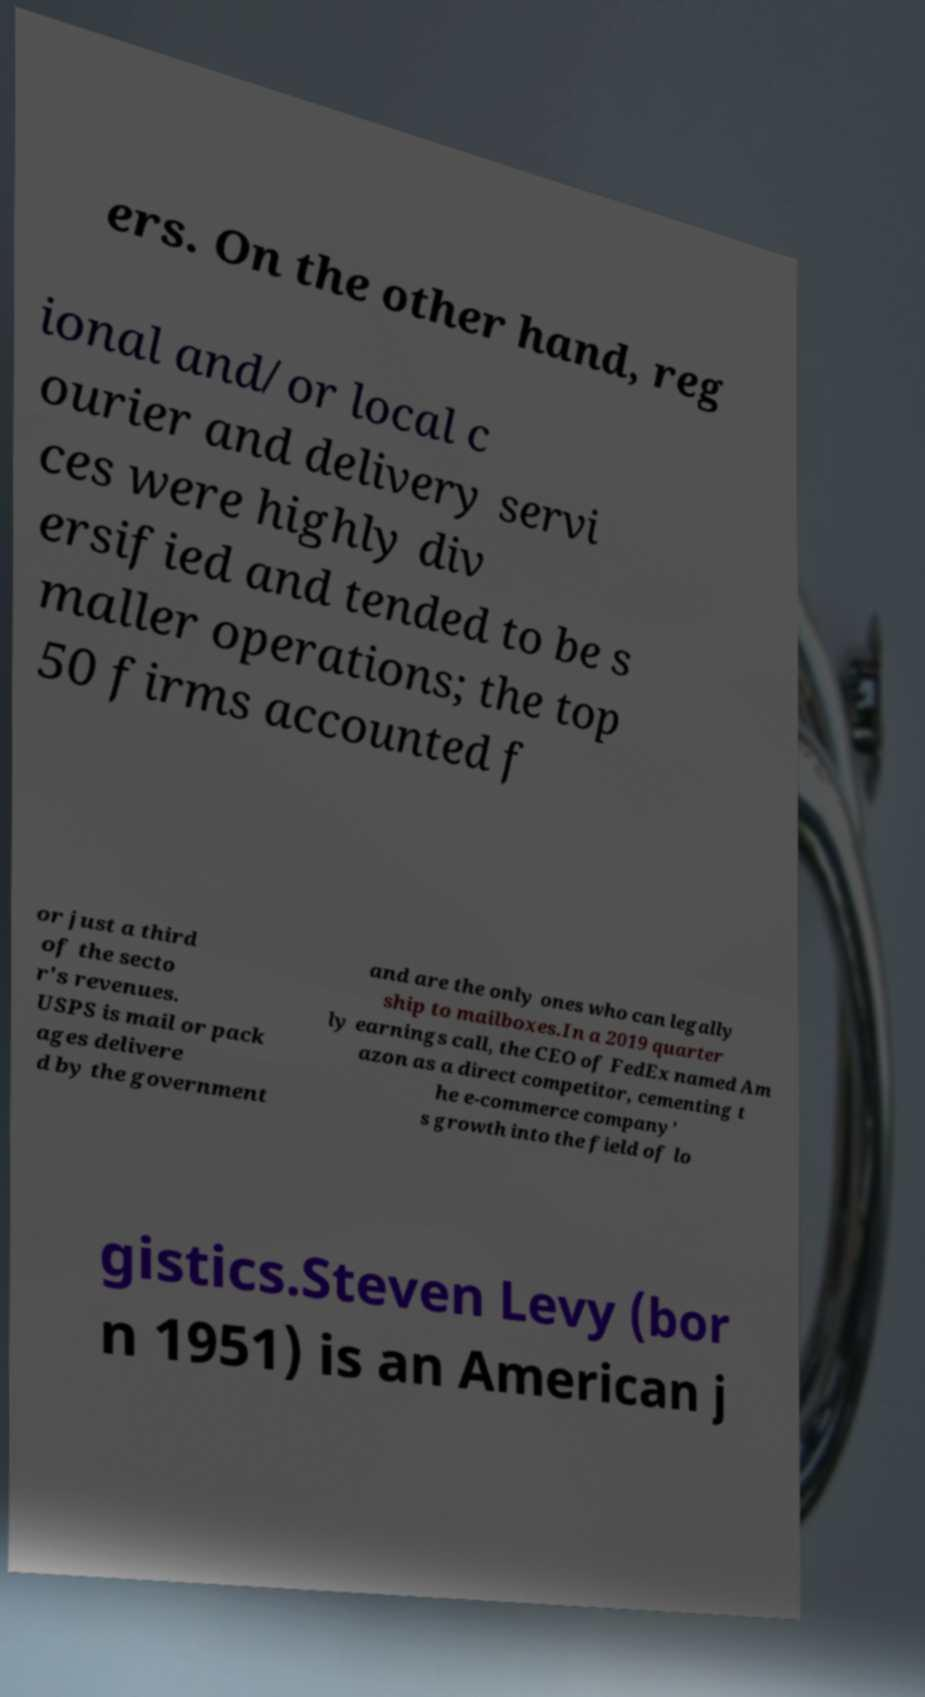Can you read and provide the text displayed in the image?This photo seems to have some interesting text. Can you extract and type it out for me? ers. On the other hand, reg ional and/or local c ourier and delivery servi ces were highly div ersified and tended to be s maller operations; the top 50 firms accounted f or just a third of the secto r's revenues. USPS is mail or pack ages delivere d by the government and are the only ones who can legally ship to mailboxes.In a 2019 quarter ly earnings call, the CEO of FedEx named Am azon as a direct competitor, cementing t he e-commerce company' s growth into the field of lo gistics.Steven Levy (bor n 1951) is an American j 